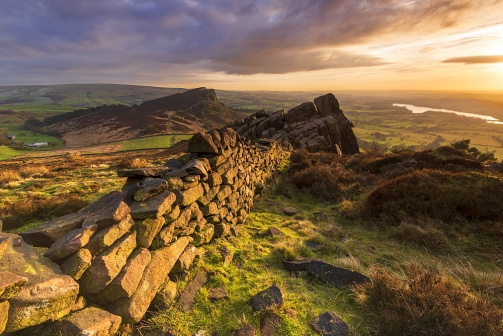Write a detailed description of the given image. The image portrays a tranquil landscape during either sunrise or sunset, as suggested by the warm orange and yellow tones lighting up the sky. The foreground features a prominent stone wall made from large, unevenly shaped rocks. This wall stretches from the left side of the image towards the right, eventually merging with a rugged rocky outcrop that sits dramatically on the edge of a steep cliff.

In the background, a scenic valley unfolds. A calm, mirror-like lake lies within the valley, bordered by gently sloping hills that fade softly into the distance. The entire scene is immersed in the golden sunlight, which casts long shadows and highlights the textures of the rocks and the grassy surface over which the wall travels. The perspective seems to be from a high vantage point, overlooking the valley below, adding a sense of grandeur and peace to the scene. 